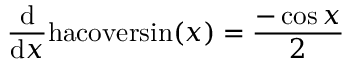Convert formula to latex. <formula><loc_0><loc_0><loc_500><loc_500>{ \frac { d } { d x } } h a c o v e r \sin ( x ) = { \frac { - \cos { x } } { 2 } }</formula> 